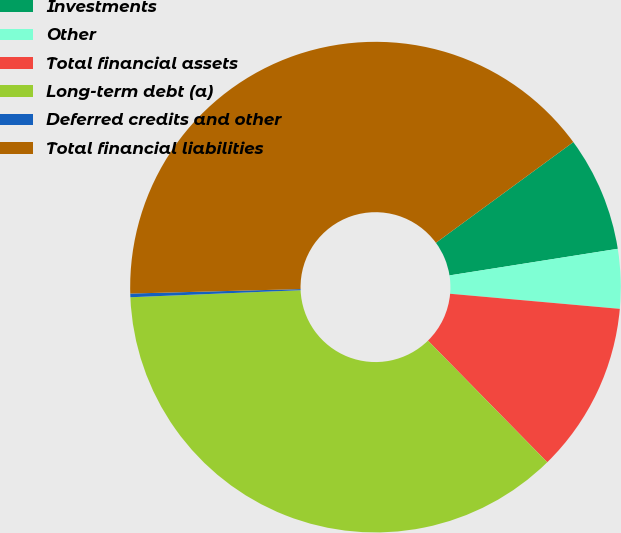<chart> <loc_0><loc_0><loc_500><loc_500><pie_chart><fcel>Investments<fcel>Other<fcel>Total financial assets<fcel>Long-term debt (a)<fcel>Deferred credits and other<fcel>Total financial liabilities<nl><fcel>7.57%<fcel>3.91%<fcel>11.24%<fcel>36.69%<fcel>0.24%<fcel>40.35%<nl></chart> 